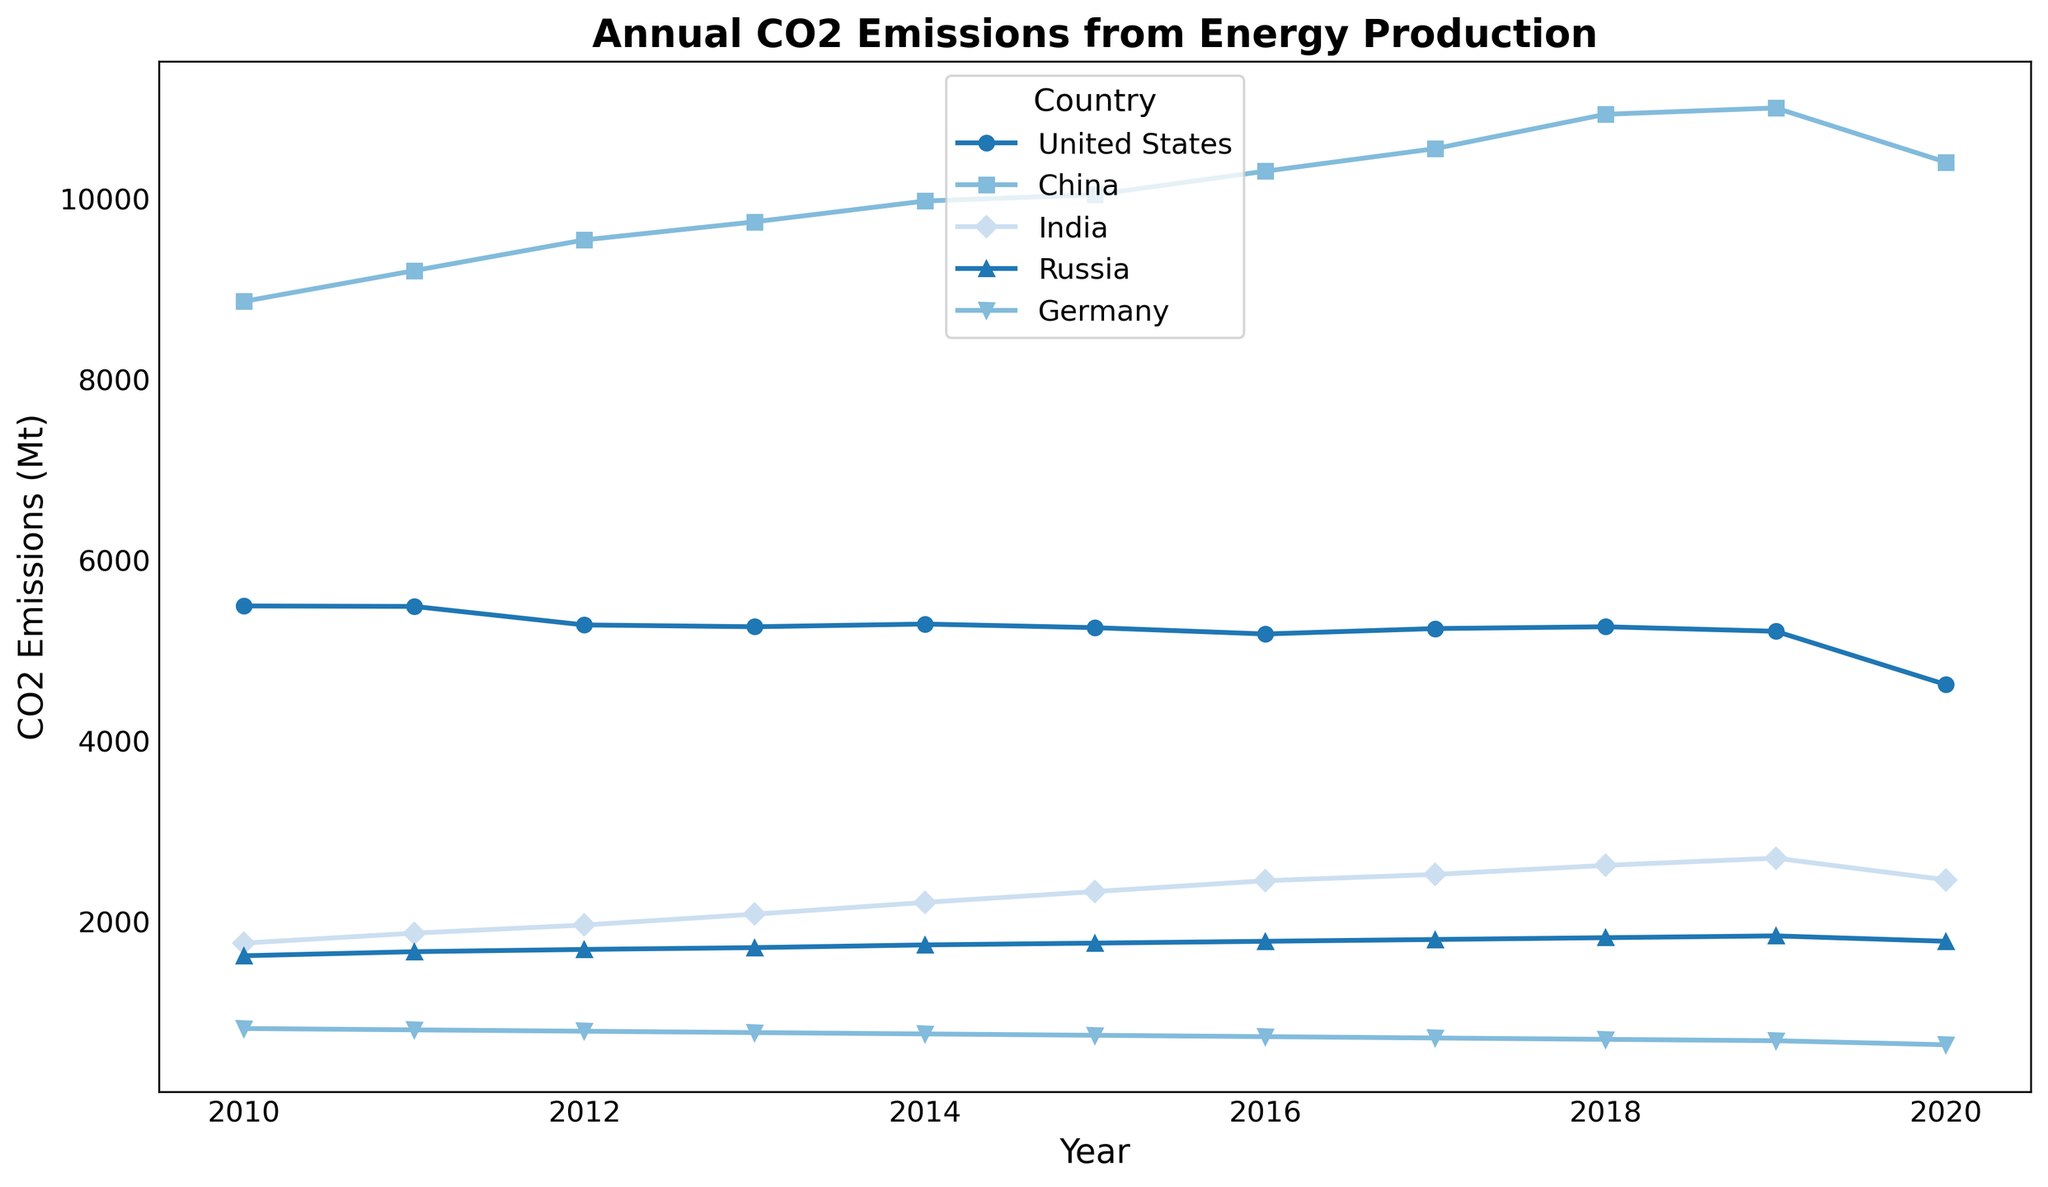What is the trend of CO2 emissions for the United States from 2010 to 2020? The line representing the United States shows a general downward trend over the years. By following the shape of the line, we see that the CO2 emissions decrease from 2010 (5490 Mt) to 2020 (4620 Mt).
Answer: Decreasing Between China and India, which country had a greater increase in CO2 emissions from 2010 to 2020? To find the increase, we subtract the 2010 value from the 2020 value for both countries. For China: 10400 - 8860 = 1540 Mt. For India: 2460 - 1760 = 700 Mt. China had a larger increase.
Answer: China In which year did the United States and Russia have the same CO2 emissions trend (increase or decrease compared to the previous year)? By inspecting the lines, we see that both the United States and Russia show a decrease in emissions between 2019 and 2020.
Answer: 2020 Which country shows the most significant drop in CO2 emissions between any two consecutive years? Visual inspection of the line plots shows that Germany has the most prominent drop between 2019 (680 Mt) and 2020 (635 Mt), amounting to a 45 Mt decrease.
Answer: Germany What is the average CO2 emissions of Germany over the decade shown? Sum all emissions values for Germany and divide by the number of years: (815 + 800 + 785 + 770 + 755 + 740 + 725 + 710 + 695 + 680 + 635) / 11 = 739.09 Mt.
Answer: 739.09 Mt Compare the CO2 emissions of Russia and India in 2017. Which country had higher emissions and by how much? From the lines, Russia had 1800 Mt and India had 2520 Mt in 2017. The difference is 2520 - 1800 = 720 Mt.
Answer: India by 720 Mt In which year did China surpass 10000 Mt in CO2 emissions, and what was the exact value? Observing the line and the plotted points, China surpassed 10000 Mt in 2015 with an emission value of 10040 Mt.
Answer: 2015, 10040 Mt 